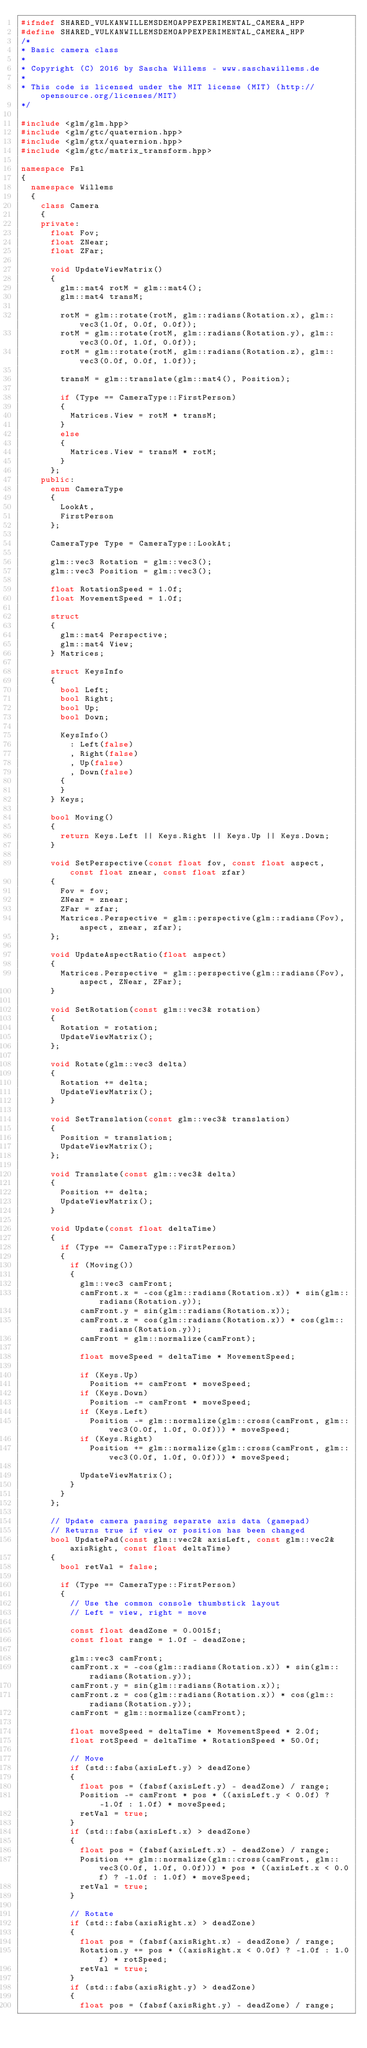<code> <loc_0><loc_0><loc_500><loc_500><_C++_>#ifndef SHARED_VULKANWILLEMSDEMOAPPEXPERIMENTAL_CAMERA_HPP
#define SHARED_VULKANWILLEMSDEMOAPPEXPERIMENTAL_CAMERA_HPP
/*
* Basic camera class
*
* Copyright (C) 2016 by Sascha Willems - www.saschawillems.de
*
* This code is licensed under the MIT license (MIT) (http://opensource.org/licenses/MIT)
*/

#include <glm/glm.hpp>
#include <glm/gtc/quaternion.hpp>
#include <glm/gtx/quaternion.hpp>
#include <glm/gtc/matrix_transform.hpp>

namespace Fsl
{
  namespace Willems
  {
    class Camera
    {
    private:
      float Fov;
      float ZNear;
      float ZFar;

      void UpdateViewMatrix()
      {
        glm::mat4 rotM = glm::mat4();
        glm::mat4 transM;

        rotM = glm::rotate(rotM, glm::radians(Rotation.x), glm::vec3(1.0f, 0.0f, 0.0f));
        rotM = glm::rotate(rotM, glm::radians(Rotation.y), glm::vec3(0.0f, 1.0f, 0.0f));
        rotM = glm::rotate(rotM, glm::radians(Rotation.z), glm::vec3(0.0f, 0.0f, 1.0f));

        transM = glm::translate(glm::mat4(), Position);

        if (Type == CameraType::FirstPerson)
        {
          Matrices.View = rotM * transM;
        }
        else
        {
          Matrices.View = transM * rotM;
        }
      };
    public:
      enum CameraType
      {
        LookAt,
        FirstPerson
      };

      CameraType Type = CameraType::LookAt;

      glm::vec3 Rotation = glm::vec3();
      glm::vec3 Position = glm::vec3();

      float RotationSpeed = 1.0f;
      float MovementSpeed = 1.0f;

      struct
      {
        glm::mat4 Perspective;
        glm::mat4 View;
      } Matrices;

      struct KeysInfo
      {
        bool Left;
        bool Right;
        bool Up;
        bool Down;

        KeysInfo()
          : Left(false)
          , Right(false)
          , Up(false)
          , Down(false)
        {
        }
      } Keys;

      bool Moving()
      {
        return Keys.Left || Keys.Right || Keys.Up || Keys.Down;
      }

      void SetPerspective(const float fov, const float aspect, const float znear, const float zfar)
      {
        Fov = fov;
        ZNear = znear;
        ZFar = zfar;
        Matrices.Perspective = glm::perspective(glm::radians(Fov), aspect, znear, zfar);
      };

      void UpdateAspectRatio(float aspect)
      {
        Matrices.Perspective = glm::perspective(glm::radians(Fov), aspect, ZNear, ZFar);
      }

      void SetRotation(const glm::vec3& rotation)
      {
        Rotation = rotation;
        UpdateViewMatrix();
      };

      void Rotate(glm::vec3 delta)
      {
        Rotation += delta;
        UpdateViewMatrix();
      }

      void SetTranslation(const glm::vec3& translation)
      {
        Position = translation;
        UpdateViewMatrix();
      };

      void Translate(const glm::vec3& delta)
      {
        Position += delta;
        UpdateViewMatrix();
      }

      void Update(const float deltaTime)
      {
        if (Type == CameraType::FirstPerson)
        {
          if (Moving())
          {
            glm::vec3 camFront;
            camFront.x = -cos(glm::radians(Rotation.x)) * sin(glm::radians(Rotation.y));
            camFront.y = sin(glm::radians(Rotation.x));
            camFront.z = cos(glm::radians(Rotation.x)) * cos(glm::radians(Rotation.y));
            camFront = glm::normalize(camFront);

            float moveSpeed = deltaTime * MovementSpeed;

            if (Keys.Up)
              Position += camFront * moveSpeed;
            if (Keys.Down)
              Position -= camFront * moveSpeed;
            if (Keys.Left)
              Position -= glm::normalize(glm::cross(camFront, glm::vec3(0.0f, 1.0f, 0.0f))) * moveSpeed;
            if (Keys.Right)
              Position += glm::normalize(glm::cross(camFront, glm::vec3(0.0f, 1.0f, 0.0f))) * moveSpeed;

            UpdateViewMatrix();
          }
        }
      };

      // Update camera passing separate axis data (gamepad)
      // Returns true if view or position has been changed
      bool UpdatePad(const glm::vec2& axisLeft, const glm::vec2& axisRight, const float deltaTime)
      {
        bool retVal = false;

        if (Type == CameraType::FirstPerson)
        {
          // Use the common console thumbstick layout
          // Left = view, right = move

          const float deadZone = 0.0015f;
          const float range = 1.0f - deadZone;

          glm::vec3 camFront;
          camFront.x = -cos(glm::radians(Rotation.x)) * sin(glm::radians(Rotation.y));
          camFront.y = sin(glm::radians(Rotation.x));
          camFront.z = cos(glm::radians(Rotation.x)) * cos(glm::radians(Rotation.y));
          camFront = glm::normalize(camFront);

          float moveSpeed = deltaTime * MovementSpeed * 2.0f;
          float rotSpeed = deltaTime * RotationSpeed * 50.0f;

          // Move
          if (std::fabs(axisLeft.y) > deadZone)
          {
            float pos = (fabsf(axisLeft.y) - deadZone) / range;
            Position -= camFront * pos * ((axisLeft.y < 0.0f) ? -1.0f : 1.0f) * moveSpeed;
            retVal = true;
          }
          if (std::fabs(axisLeft.x) > deadZone)
          {
            float pos = (fabsf(axisLeft.x) - deadZone) / range;
            Position += glm::normalize(glm::cross(camFront, glm::vec3(0.0f, 1.0f, 0.0f))) * pos * ((axisLeft.x < 0.0f) ? -1.0f : 1.0f) * moveSpeed;
            retVal = true;
          }

          // Rotate
          if (std::fabs(axisRight.x) > deadZone)
          {
            float pos = (fabsf(axisRight.x) - deadZone) / range;
            Rotation.y += pos * ((axisRight.x < 0.0f) ? -1.0f : 1.0f) * rotSpeed;
            retVal = true;
          }
          if (std::fabs(axisRight.y) > deadZone)
          {
            float pos = (fabsf(axisRight.y) - deadZone) / range;</code> 